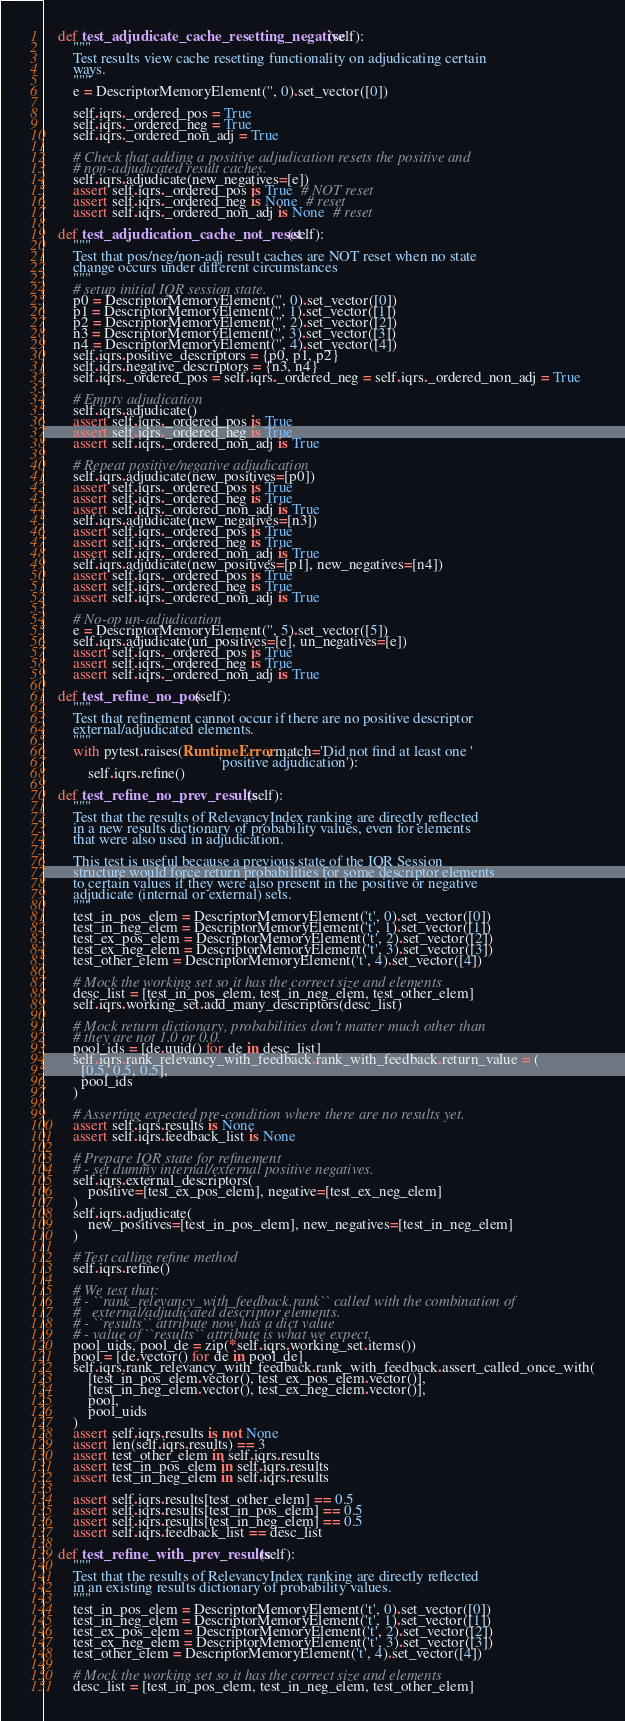Convert code to text. <code><loc_0><loc_0><loc_500><loc_500><_Python_>
    def test_adjudicate_cache_resetting_negative(self):
        """
        Test results view cache resetting functionality on adjudicating certain
        ways.
        """
        e = DescriptorMemoryElement('', 0).set_vector([0])

        self.iqrs._ordered_pos = True
        self.iqrs._ordered_neg = True
        self.iqrs._ordered_non_adj = True

        # Check that adding a positive adjudication resets the positive and
        # non-adjudicated result caches.
        self.iqrs.adjudicate(new_negatives=[e])
        assert self.iqrs._ordered_pos is True  # NOT reset
        assert self.iqrs._ordered_neg is None  # reset
        assert self.iqrs._ordered_non_adj is None  # reset

    def test_adjudication_cache_not_reset(self):
        """
        Test that pos/neg/non-adj result caches are NOT reset when no state
        change occurs under different circumstances
        """
        # setup initial IQR session state.
        p0 = DescriptorMemoryElement('', 0).set_vector([0])
        p1 = DescriptorMemoryElement('', 1).set_vector([1])
        p2 = DescriptorMemoryElement('', 2).set_vector([2])
        n3 = DescriptorMemoryElement('', 3).set_vector([3])
        n4 = DescriptorMemoryElement('', 4).set_vector([4])
        self.iqrs.positive_descriptors = {p0, p1, p2}
        self.iqrs.negative_descriptors = {n3, n4}
        self.iqrs._ordered_pos = self.iqrs._ordered_neg = self.iqrs._ordered_non_adj = True

        # Empty adjudication
        self.iqrs.adjudicate()
        assert self.iqrs._ordered_pos is True
        assert self.iqrs._ordered_neg is True
        assert self.iqrs._ordered_non_adj is True

        # Repeat positive/negative adjudication
        self.iqrs.adjudicate(new_positives=[p0])
        assert self.iqrs._ordered_pos is True
        assert self.iqrs._ordered_neg is True
        assert self.iqrs._ordered_non_adj is True
        self.iqrs.adjudicate(new_negatives=[n3])
        assert self.iqrs._ordered_pos is True
        assert self.iqrs._ordered_neg is True
        assert self.iqrs._ordered_non_adj is True
        self.iqrs.adjudicate(new_positives=[p1], new_negatives=[n4])
        assert self.iqrs._ordered_pos is True
        assert self.iqrs._ordered_neg is True
        assert self.iqrs._ordered_non_adj is True

        # No-op un-adjudication
        e = DescriptorMemoryElement('', 5).set_vector([5])
        self.iqrs.adjudicate(un_positives=[e], un_negatives=[e])
        assert self.iqrs._ordered_pos is True
        assert self.iqrs._ordered_neg is True
        assert self.iqrs._ordered_non_adj is True

    def test_refine_no_pos(self):
        """
        Test that refinement cannot occur if there are no positive descriptor
        external/adjudicated elements.
        """
        with pytest.raises(RuntimeError, match='Did not find at least one '
                                               'positive adjudication'):
            self.iqrs.refine()

    def test_refine_no_prev_results(self):
        """
        Test that the results of RelevancyIndex ranking are directly reflected
        in a new results dictionary of probability values, even for elements
        that were also used in adjudication.

        This test is useful because a previous state of the IQR Session
        structure would force return probabilities for some descriptor elements
        to certain values if they were also present in the positive or negative
        adjudicate (internal or external) sets.
        """
        test_in_pos_elem = DescriptorMemoryElement('t', 0).set_vector([0])
        test_in_neg_elem = DescriptorMemoryElement('t', 1).set_vector([1])
        test_ex_pos_elem = DescriptorMemoryElement('t', 2).set_vector([2])
        test_ex_neg_elem = DescriptorMemoryElement('t', 3).set_vector([3])
        test_other_elem = DescriptorMemoryElement('t', 4).set_vector([4])

        # Mock the working set so it has the correct size and elements
        desc_list = [test_in_pos_elem, test_in_neg_elem, test_other_elem]
        self.iqrs.working_set.add_many_descriptors(desc_list)

        # Mock return dictionary, probabilities don't matter much other than
        # they are not 1.0 or 0.0.
        pool_ids = [de.uuid() for de in desc_list]
        self.iqrs.rank_relevancy_with_feedback.rank_with_feedback.return_value = (
          [0.5, 0.5, 0.5],
          pool_ids
        )

        # Asserting expected pre-condition where there are no results yet.
        assert self.iqrs.results is None
        assert self.iqrs.feedback_list is None

        # Prepare IQR state for refinement
        # - set dummy internal/external positive negatives.
        self.iqrs.external_descriptors(
            positive=[test_ex_pos_elem], negative=[test_ex_neg_elem]
        )
        self.iqrs.adjudicate(
            new_positives=[test_in_pos_elem], new_negatives=[test_in_neg_elem]
        )

        # Test calling refine method
        self.iqrs.refine()

        # We test that:
        # - ``rank_relevancy_with_feedback.rank`` called with the combination of
        #   external/adjudicated descriptor elements.
        # - ``results`` attribute now has a dict value
        # - value of ``results`` attribute is what we expect.
        pool_uids, pool_de = zip(*self.iqrs.working_set.items())
        pool = [de.vector() for de in pool_de]
        self.iqrs.rank_relevancy_with_feedback.rank_with_feedback.assert_called_once_with(
            [test_in_pos_elem.vector(), test_ex_pos_elem.vector()],
            [test_in_neg_elem.vector(), test_ex_neg_elem.vector()],
            pool,
            pool_uids
        )
        assert self.iqrs.results is not None
        assert len(self.iqrs.results) == 3
        assert test_other_elem in self.iqrs.results
        assert test_in_pos_elem in self.iqrs.results
        assert test_in_neg_elem in self.iqrs.results

        assert self.iqrs.results[test_other_elem] == 0.5
        assert self.iqrs.results[test_in_pos_elem] == 0.5
        assert self.iqrs.results[test_in_neg_elem] == 0.5
        assert self.iqrs.feedback_list == desc_list

    def test_refine_with_prev_results(self):
        """
        Test that the results of RelevancyIndex ranking are directly reflected
        in an existing results dictionary of probability values.
        """
        test_in_pos_elem = DescriptorMemoryElement('t', 0).set_vector([0])
        test_in_neg_elem = DescriptorMemoryElement('t', 1).set_vector([1])
        test_ex_pos_elem = DescriptorMemoryElement('t', 2).set_vector([2])
        test_ex_neg_elem = DescriptorMemoryElement('t', 3).set_vector([3])
        test_other_elem = DescriptorMemoryElement('t', 4).set_vector([4])

        # Mock the working set so it has the correct size and elements
        desc_list = [test_in_pos_elem, test_in_neg_elem, test_other_elem]</code> 